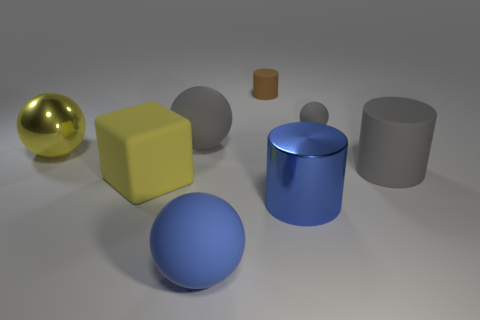There is another small thing that is the same shape as the blue metal thing; what color is it?
Your response must be concise. Brown. How many big things are either blue rubber things or green cubes?
Offer a terse response. 1. There is a brown rubber thing that is on the left side of the large metal cylinder; what size is it?
Make the answer very short. Small. Is there another small sphere of the same color as the small ball?
Make the answer very short. No. Is the color of the small sphere the same as the big rubber cube?
Offer a terse response. No. The matte object that is the same color as the shiny cylinder is what shape?
Offer a very short reply. Sphere. There is a large shiny sphere on the left side of the big matte block; what number of large shiny cylinders are behind it?
Your answer should be very brief. 0. How many big green cylinders have the same material as the small ball?
Make the answer very short. 0. There is a blue rubber sphere; are there any large metallic objects to the left of it?
Your answer should be very brief. Yes. What is the color of the shiny cylinder that is the same size as the yellow rubber thing?
Ensure brevity in your answer.  Blue. 